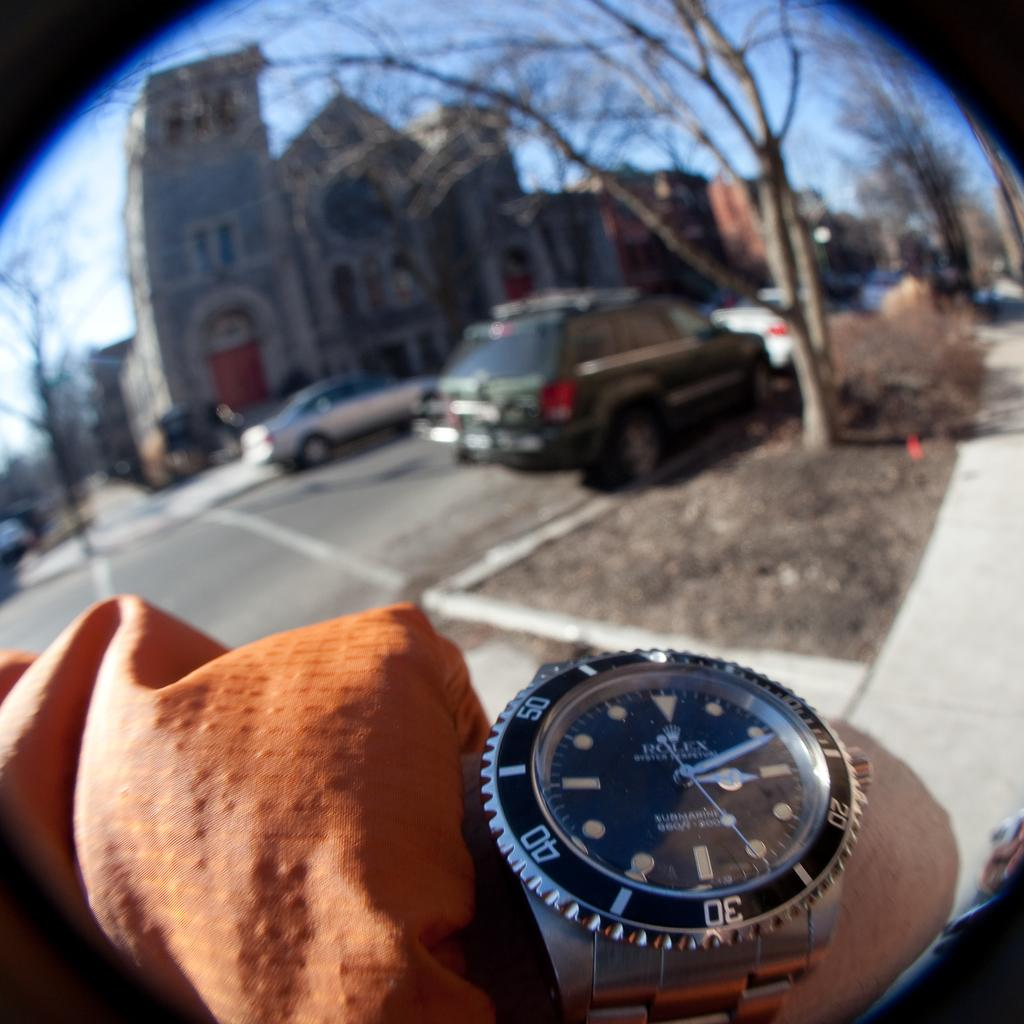<image>
Provide a brief description of the given image. A person stands in a parking lot and shows their Rolex watch to the camera. 